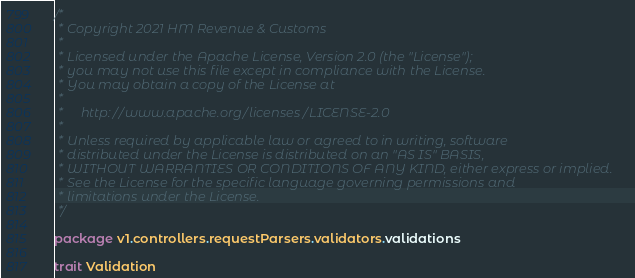<code> <loc_0><loc_0><loc_500><loc_500><_Scala_>/*
 * Copyright 2021 HM Revenue & Customs
 *
 * Licensed under the Apache License, Version 2.0 (the "License");
 * you may not use this file except in compliance with the License.
 * You may obtain a copy of the License at
 *
 *     http://www.apache.org/licenses/LICENSE-2.0
 *
 * Unless required by applicable law or agreed to in writing, software
 * distributed under the License is distributed on an "AS IS" BASIS,
 * WITHOUT WARRANTIES OR CONDITIONS OF ANY KIND, either express or implied.
 * See the License for the specific language governing permissions and
 * limitations under the License.
 */

package v1.controllers.requestParsers.validators.validations

trait Validation
</code> 